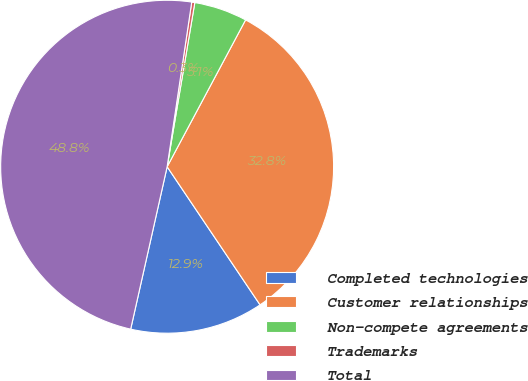<chart> <loc_0><loc_0><loc_500><loc_500><pie_chart><fcel>Completed technologies<fcel>Customer relationships<fcel>Non-compete agreements<fcel>Trademarks<fcel>Total<nl><fcel>12.94%<fcel>32.77%<fcel>5.15%<fcel>0.3%<fcel>48.85%<nl></chart> 